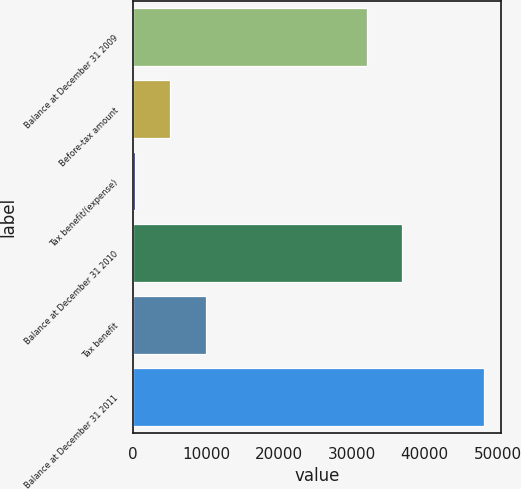Convert chart. <chart><loc_0><loc_0><loc_500><loc_500><bar_chart><fcel>Balance at December 31 2009<fcel>Before-tax amount<fcel>Tax benefit/(expense)<fcel>Balance at December 31 2010<fcel>Tax benefit<fcel>Balance at December 31 2011<nl><fcel>32127<fcel>5013.3<fcel>227<fcel>36913.3<fcel>10022<fcel>48090<nl></chart> 